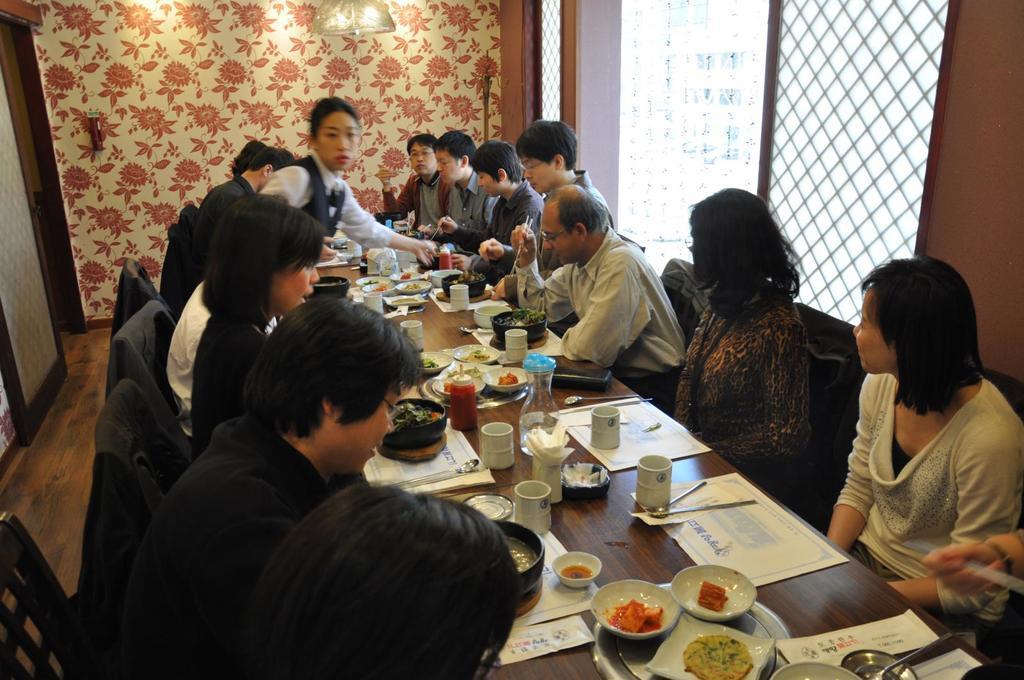Please provide a concise description of this image. It looks like a team lunch, group of people are sitting around the table on the either side lot of food items are placed on the table, a woman who is standing to the left side is serving the food there is a cream color wall with red color flowers in the background. 